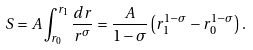<formula> <loc_0><loc_0><loc_500><loc_500>S = A \int _ { r _ { 0 } } ^ { r _ { 1 } } \frac { d r } { r ^ { \sigma } } = \frac { A } { 1 - \sigma } \left ( r _ { 1 } ^ { 1 - \sigma } - r _ { 0 } ^ { 1 - \sigma } \right ) .</formula> 